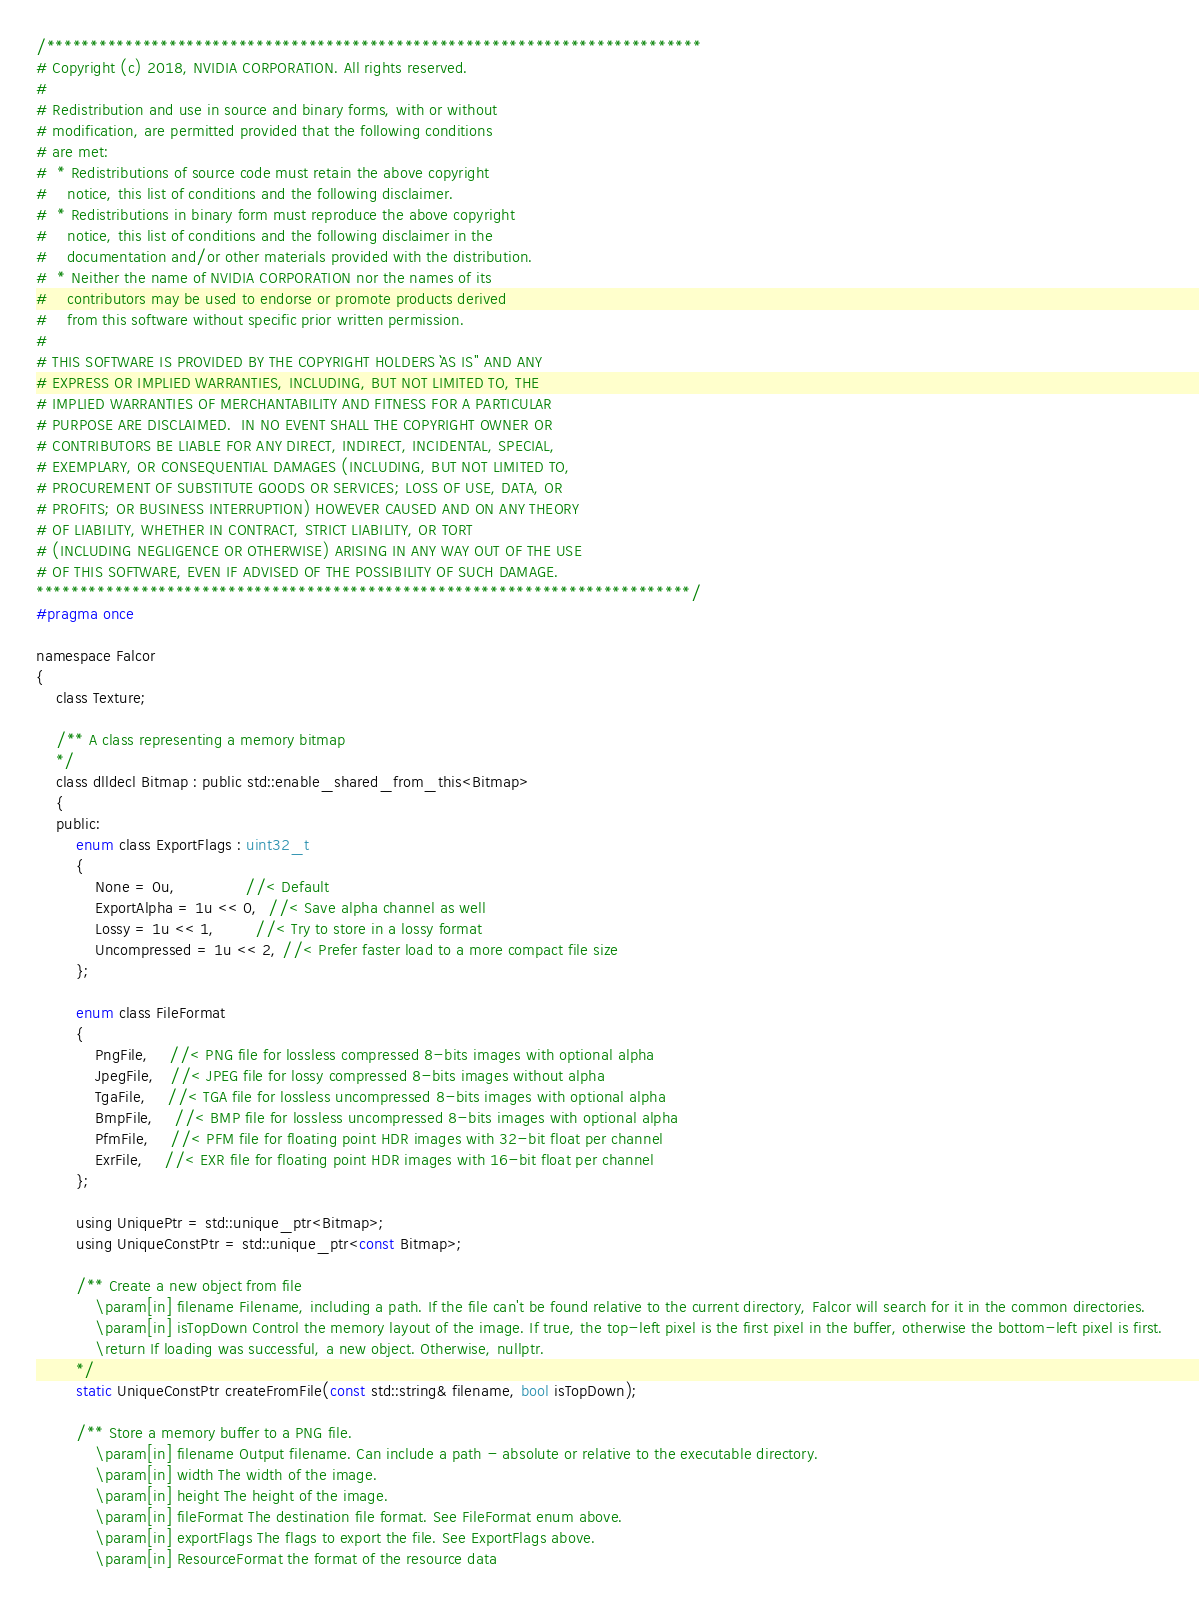<code> <loc_0><loc_0><loc_500><loc_500><_C_>/***************************************************************************
# Copyright (c) 2018, NVIDIA CORPORATION. All rights reserved.
#
# Redistribution and use in source and binary forms, with or without
# modification, are permitted provided that the following conditions
# are met:
#  * Redistributions of source code must retain the above copyright
#    notice, this list of conditions and the following disclaimer.
#  * Redistributions in binary form must reproduce the above copyright
#    notice, this list of conditions and the following disclaimer in the
#    documentation and/or other materials provided with the distribution.
#  * Neither the name of NVIDIA CORPORATION nor the names of its
#    contributors may be used to endorse or promote products derived
#    from this software without specific prior written permission.
#
# THIS SOFTWARE IS PROVIDED BY THE COPYRIGHT HOLDERS ``AS IS'' AND ANY
# EXPRESS OR IMPLIED WARRANTIES, INCLUDING, BUT NOT LIMITED TO, THE
# IMPLIED WARRANTIES OF MERCHANTABILITY AND FITNESS FOR A PARTICULAR
# PURPOSE ARE DISCLAIMED.  IN NO EVENT SHALL THE COPYRIGHT OWNER OR
# CONTRIBUTORS BE LIABLE FOR ANY DIRECT, INDIRECT, INCIDENTAL, SPECIAL,
# EXEMPLARY, OR CONSEQUENTIAL DAMAGES (INCLUDING, BUT NOT LIMITED TO,
# PROCUREMENT OF SUBSTITUTE GOODS OR SERVICES; LOSS OF USE, DATA, OR
# PROFITS; OR BUSINESS INTERRUPTION) HOWEVER CAUSED AND ON ANY THEORY
# OF LIABILITY, WHETHER IN CONTRACT, STRICT LIABILITY, OR TORT
# (INCLUDING NEGLIGENCE OR OTHERWISE) ARISING IN ANY WAY OUT OF THE USE
# OF THIS SOFTWARE, EVEN IF ADVISED OF THE POSSIBILITY OF SUCH DAMAGE.
***************************************************************************/
#pragma once

namespace Falcor
{
    class Texture;

    /** A class representing a memory bitmap
    */
    class dlldecl Bitmap : public std::enable_shared_from_this<Bitmap>
    {
    public:
        enum class ExportFlags : uint32_t
        {
            None = 0u,              //< Default
            ExportAlpha = 1u << 0,  //< Save alpha channel as well
            Lossy = 1u << 1,        //< Try to store in a lossy format
            Uncompressed = 1u << 2, //< Prefer faster load to a more compact file size
        };

        enum class FileFormat
        {
            PngFile,    //< PNG file for lossless compressed 8-bits images with optional alpha
            JpegFile,   //< JPEG file for lossy compressed 8-bits images without alpha
            TgaFile,    //< TGA file for lossless uncompressed 8-bits images with optional alpha
            BmpFile,    //< BMP file for lossless uncompressed 8-bits images with optional alpha
            PfmFile,    //< PFM file for floating point HDR images with 32-bit float per channel
            ExrFile,    //< EXR file for floating point HDR images with 16-bit float per channel
        };

        using UniquePtr = std::unique_ptr<Bitmap>;
        using UniqueConstPtr = std::unique_ptr<const Bitmap>;

        /** Create a new object from file
            \param[in] filename Filename, including a path. If the file can't be found relative to the current directory, Falcor will search for it in the common directories.
            \param[in] isTopDown Control the memory layout of the image. If true, the top-left pixel is the first pixel in the buffer, otherwise the bottom-left pixel is first.
            \return If loading was successful, a new object. Otherwise, nullptr.
        */
        static UniqueConstPtr createFromFile(const std::string& filename, bool isTopDown);

        /** Store a memory buffer to a PNG file.
            \param[in] filename Output filename. Can include a path - absolute or relative to the executable directory.
            \param[in] width The width of the image.
            \param[in] height The height of the image.
            \param[in] fileFormat The destination file format. See FileFormat enum above.
            \param[in] exportFlags The flags to export the file. See ExportFlags above.
            \param[in] ResourceFormat the format of the resource data</code> 